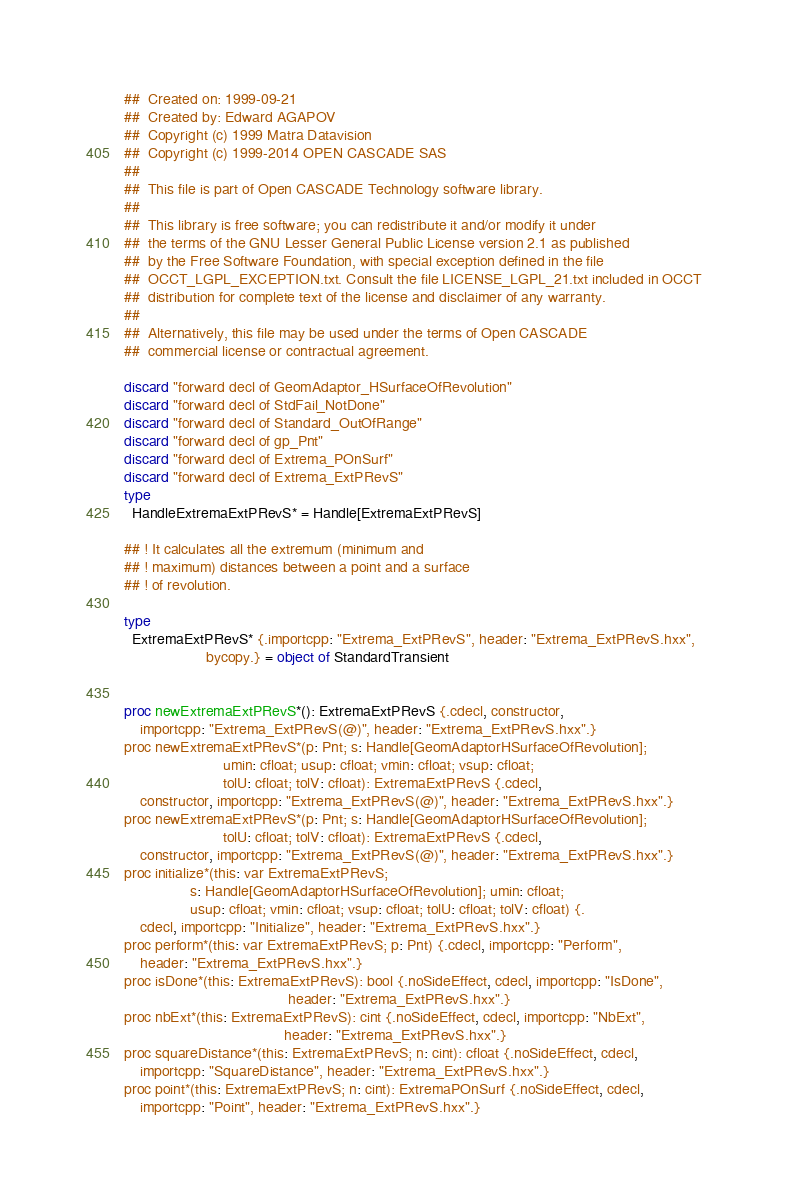Convert code to text. <code><loc_0><loc_0><loc_500><loc_500><_Nim_>##  Created on: 1999-09-21
##  Created by: Edward AGAPOV
##  Copyright (c) 1999 Matra Datavision
##  Copyright (c) 1999-2014 OPEN CASCADE SAS
##
##  This file is part of Open CASCADE Technology software library.
##
##  This library is free software; you can redistribute it and/or modify it under
##  the terms of the GNU Lesser General Public License version 2.1 as published
##  by the Free Software Foundation, with special exception defined in the file
##  OCCT_LGPL_EXCEPTION.txt. Consult the file LICENSE_LGPL_21.txt included in OCCT
##  distribution for complete text of the license and disclaimer of any warranty.
##
##  Alternatively, this file may be used under the terms of Open CASCADE
##  commercial license or contractual agreement.

discard "forward decl of GeomAdaptor_HSurfaceOfRevolution"
discard "forward decl of StdFail_NotDone"
discard "forward decl of Standard_OutOfRange"
discard "forward decl of gp_Pnt"
discard "forward decl of Extrema_POnSurf"
discard "forward decl of Extrema_ExtPRevS"
type
  HandleExtremaExtPRevS* = Handle[ExtremaExtPRevS]

## ! It calculates all the extremum (minimum and
## ! maximum) distances between a point and a surface
## ! of revolution.

type
  ExtremaExtPRevS* {.importcpp: "Extrema_ExtPRevS", header: "Extrema_ExtPRevS.hxx",
                    bycopy.} = object of StandardTransient


proc newExtremaExtPRevS*(): ExtremaExtPRevS {.cdecl, constructor,
    importcpp: "Extrema_ExtPRevS(@)", header: "Extrema_ExtPRevS.hxx".}
proc newExtremaExtPRevS*(p: Pnt; s: Handle[GeomAdaptorHSurfaceOfRevolution];
                        umin: cfloat; usup: cfloat; vmin: cfloat; vsup: cfloat;
                        tolU: cfloat; tolV: cfloat): ExtremaExtPRevS {.cdecl,
    constructor, importcpp: "Extrema_ExtPRevS(@)", header: "Extrema_ExtPRevS.hxx".}
proc newExtremaExtPRevS*(p: Pnt; s: Handle[GeomAdaptorHSurfaceOfRevolution];
                        tolU: cfloat; tolV: cfloat): ExtremaExtPRevS {.cdecl,
    constructor, importcpp: "Extrema_ExtPRevS(@)", header: "Extrema_ExtPRevS.hxx".}
proc initialize*(this: var ExtremaExtPRevS;
                s: Handle[GeomAdaptorHSurfaceOfRevolution]; umin: cfloat;
                usup: cfloat; vmin: cfloat; vsup: cfloat; tolU: cfloat; tolV: cfloat) {.
    cdecl, importcpp: "Initialize", header: "Extrema_ExtPRevS.hxx".}
proc perform*(this: var ExtremaExtPRevS; p: Pnt) {.cdecl, importcpp: "Perform",
    header: "Extrema_ExtPRevS.hxx".}
proc isDone*(this: ExtremaExtPRevS): bool {.noSideEffect, cdecl, importcpp: "IsDone",
                                        header: "Extrema_ExtPRevS.hxx".}
proc nbExt*(this: ExtremaExtPRevS): cint {.noSideEffect, cdecl, importcpp: "NbExt",
                                       header: "Extrema_ExtPRevS.hxx".}
proc squareDistance*(this: ExtremaExtPRevS; n: cint): cfloat {.noSideEffect, cdecl,
    importcpp: "SquareDistance", header: "Extrema_ExtPRevS.hxx".}
proc point*(this: ExtremaExtPRevS; n: cint): ExtremaPOnSurf {.noSideEffect, cdecl,
    importcpp: "Point", header: "Extrema_ExtPRevS.hxx".}</code> 